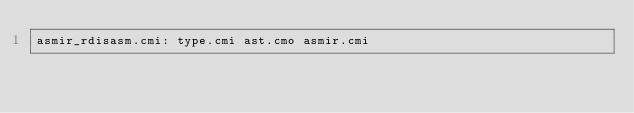Convert code to text. <code><loc_0><loc_0><loc_500><loc_500><_D_>asmir_rdisasm.cmi: type.cmi ast.cmo asmir.cmi
</code> 